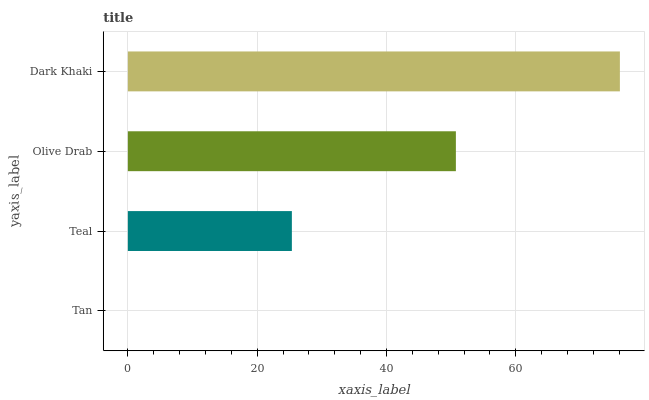Is Tan the minimum?
Answer yes or no. Yes. Is Dark Khaki the maximum?
Answer yes or no. Yes. Is Teal the minimum?
Answer yes or no. No. Is Teal the maximum?
Answer yes or no. No. Is Teal greater than Tan?
Answer yes or no. Yes. Is Tan less than Teal?
Answer yes or no. Yes. Is Tan greater than Teal?
Answer yes or no. No. Is Teal less than Tan?
Answer yes or no. No. Is Olive Drab the high median?
Answer yes or no. Yes. Is Teal the low median?
Answer yes or no. Yes. Is Dark Khaki the high median?
Answer yes or no. No. Is Tan the low median?
Answer yes or no. No. 